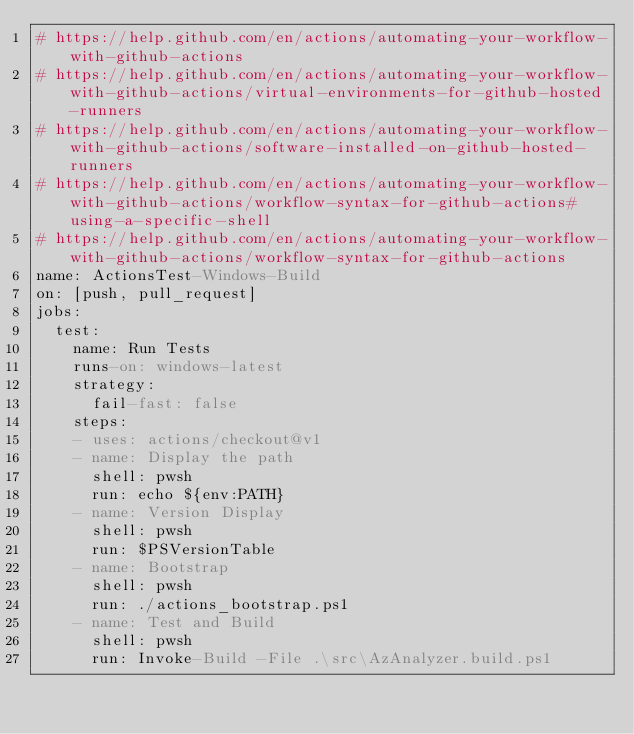<code> <loc_0><loc_0><loc_500><loc_500><_YAML_># https://help.github.com/en/actions/automating-your-workflow-with-github-actions
# https://help.github.com/en/actions/automating-your-workflow-with-github-actions/virtual-environments-for-github-hosted-runners
# https://help.github.com/en/actions/automating-your-workflow-with-github-actions/software-installed-on-github-hosted-runners
# https://help.github.com/en/actions/automating-your-workflow-with-github-actions/workflow-syntax-for-github-actions#using-a-specific-shell
# https://help.github.com/en/actions/automating-your-workflow-with-github-actions/workflow-syntax-for-github-actions
name: ActionsTest-Windows-Build
on: [push, pull_request]
jobs:
  test:
    name: Run Tests
    runs-on: windows-latest
    strategy:
      fail-fast: false
    steps:
    - uses: actions/checkout@v1
    - name: Display the path
      shell: pwsh
      run: echo ${env:PATH}
    - name: Version Display
      shell: pwsh
      run: $PSVersionTable
    - name: Bootstrap
      shell: pwsh
      run: ./actions_bootstrap.ps1
    - name: Test and Build
      shell: pwsh
      run: Invoke-Build -File .\src\AzAnalyzer.build.ps1
</code> 